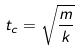Convert formula to latex. <formula><loc_0><loc_0><loc_500><loc_500>t _ { c } = \sqrt { \frac { m } { k } }</formula> 